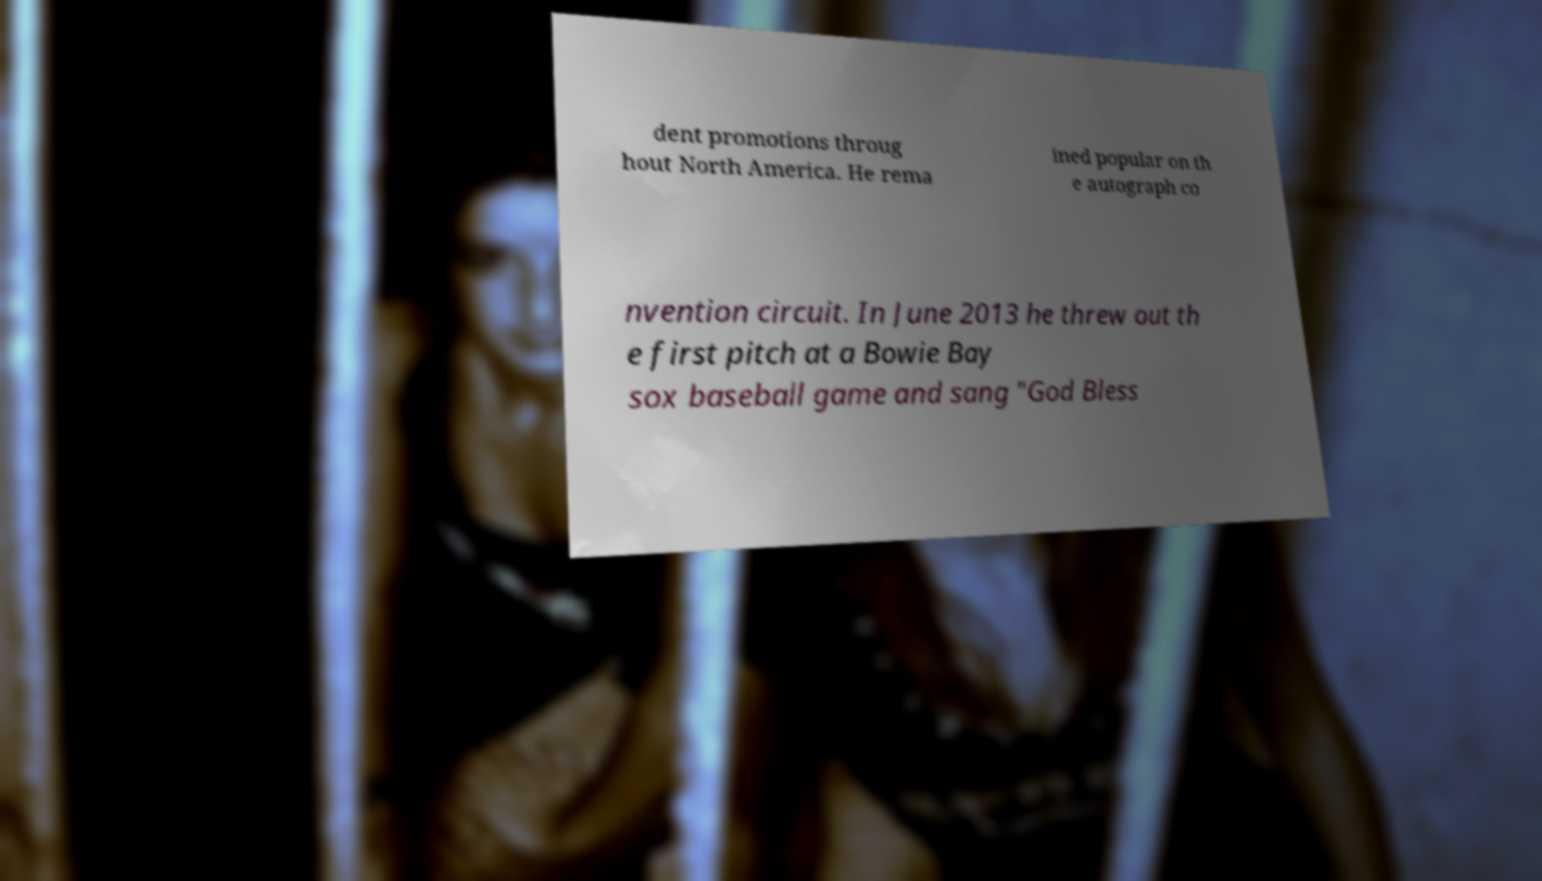Can you accurately transcribe the text from the provided image for me? dent promotions throug hout North America. He rema ined popular on th e autograph co nvention circuit. In June 2013 he threw out th e first pitch at a Bowie Bay sox baseball game and sang "God Bless 